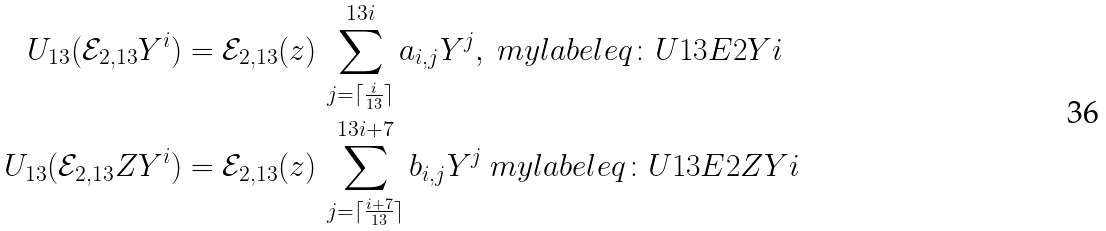Convert formula to latex. <formula><loc_0><loc_0><loc_500><loc_500>U _ { 1 3 } ( \mathcal { E } _ { 2 , { 1 3 } } Y ^ { i } ) & = \mathcal { E } _ { 2 , { 1 3 } } ( z ) \, \sum _ { j = \lceil \frac { i } { 1 3 } \rceil } ^ { 1 3 i } a _ { i , j } Y ^ { j } , \ m y l a b e l { e q \colon U { 1 3 } E 2 Y i } \\ U _ { 1 3 } ( \mathcal { E } _ { 2 , { 1 3 } } Z Y ^ { i } ) & = \mathcal { E } _ { 2 , { 1 3 } } ( z ) \, \sum _ { j = \lceil \frac { i + 7 } { 1 3 } \rceil } ^ { 1 3 i + 7 } b _ { i , j } Y ^ { j } \ m y l a b e l { e q \colon U 1 3 E 2 Z Y i }</formula> 